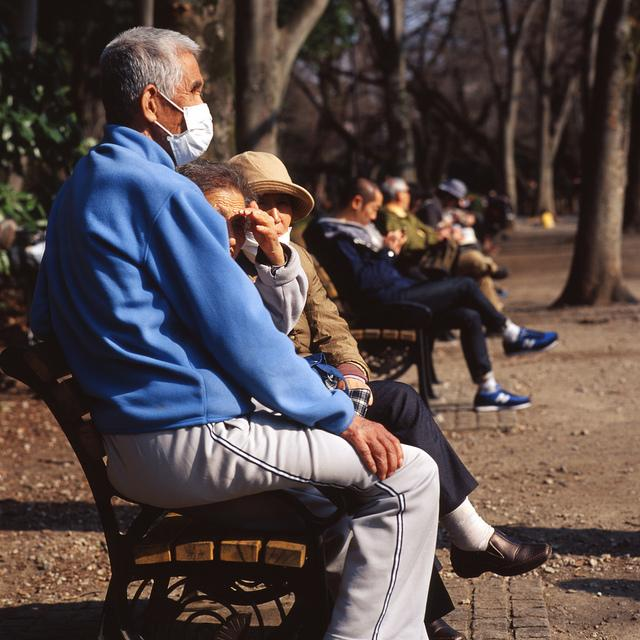What should the woman sitting in the middle wear for protection? Please explain your reasoning. sunglasses. A man is sitting on a bench outdoors on a sunny day. 